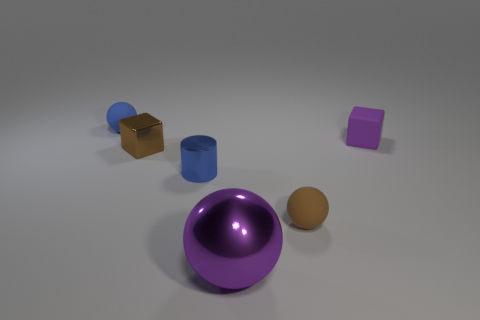Subtract all blue spheres. How many spheres are left? 2 Add 1 shiny cylinders. How many objects exist? 7 Subtract all purple balls. How many balls are left? 2 Subtract all yellow balls. How many cyan cylinders are left? 0 Subtract all red objects. Subtract all tiny metallic cylinders. How many objects are left? 5 Add 1 large metallic spheres. How many large metallic spheres are left? 2 Add 1 red metallic objects. How many red metallic objects exist? 1 Subtract 0 green cylinders. How many objects are left? 6 Subtract all cylinders. How many objects are left? 5 Subtract 1 cylinders. How many cylinders are left? 0 